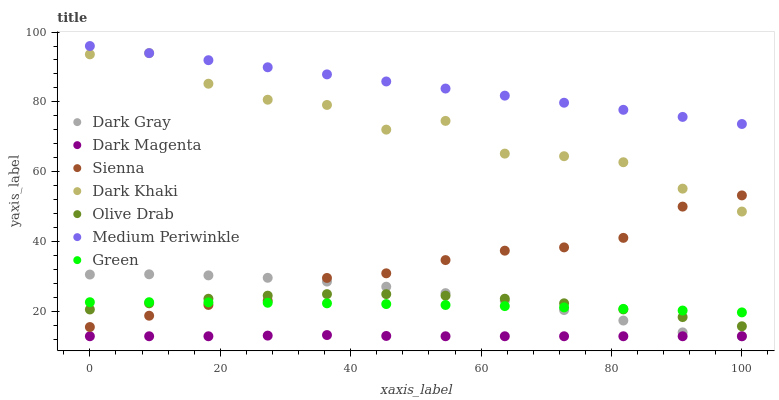Does Dark Magenta have the minimum area under the curve?
Answer yes or no. Yes. Does Medium Periwinkle have the maximum area under the curve?
Answer yes or no. Yes. Does Medium Periwinkle have the minimum area under the curve?
Answer yes or no. No. Does Dark Magenta have the maximum area under the curve?
Answer yes or no. No. Is Medium Periwinkle the smoothest?
Answer yes or no. Yes. Is Dark Khaki the roughest?
Answer yes or no. Yes. Is Dark Magenta the smoothest?
Answer yes or no. No. Is Dark Magenta the roughest?
Answer yes or no. No. Does Dark Magenta have the lowest value?
Answer yes or no. Yes. Does Medium Periwinkle have the lowest value?
Answer yes or no. No. Does Medium Periwinkle have the highest value?
Answer yes or no. Yes. Does Dark Magenta have the highest value?
Answer yes or no. No. Is Dark Magenta less than Olive Drab?
Answer yes or no. Yes. Is Olive Drab greater than Dark Magenta?
Answer yes or no. Yes. Does Olive Drab intersect Sienna?
Answer yes or no. Yes. Is Olive Drab less than Sienna?
Answer yes or no. No. Is Olive Drab greater than Sienna?
Answer yes or no. No. Does Dark Magenta intersect Olive Drab?
Answer yes or no. No. 